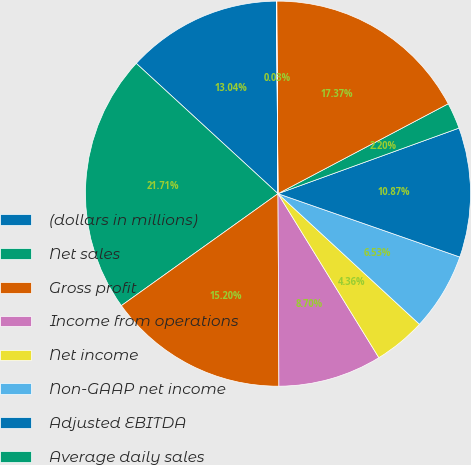Convert chart to OTSL. <chart><loc_0><loc_0><loc_500><loc_500><pie_chart><fcel>(dollars in millions)<fcel>Net sales<fcel>Gross profit<fcel>Income from operations<fcel>Net income<fcel>Non-GAAP net income<fcel>Adjusted EBITDA<fcel>Average daily sales<fcel>Net debt (1)<fcel>Cash conversion cycle (in<nl><fcel>13.04%<fcel>21.71%<fcel>15.2%<fcel>8.7%<fcel>4.36%<fcel>6.53%<fcel>10.87%<fcel>2.2%<fcel>17.37%<fcel>0.03%<nl></chart> 